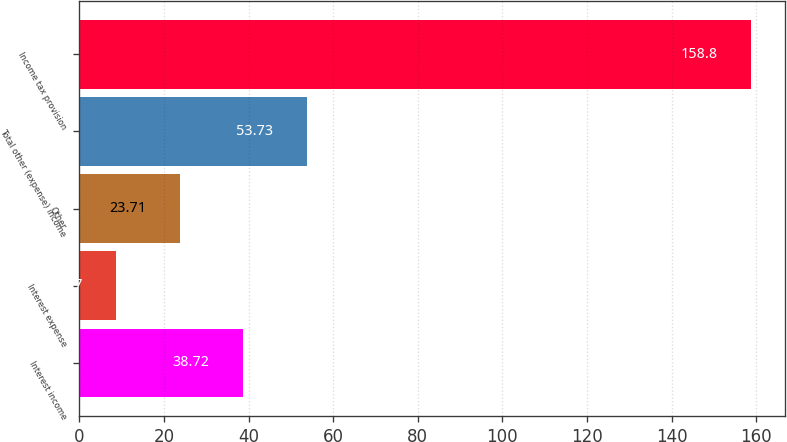Convert chart. <chart><loc_0><loc_0><loc_500><loc_500><bar_chart><fcel>Interest income<fcel>Interest expense<fcel>Other<fcel>Total other (expense) income<fcel>Income tax provision<nl><fcel>38.72<fcel>8.7<fcel>23.71<fcel>53.73<fcel>158.8<nl></chart> 